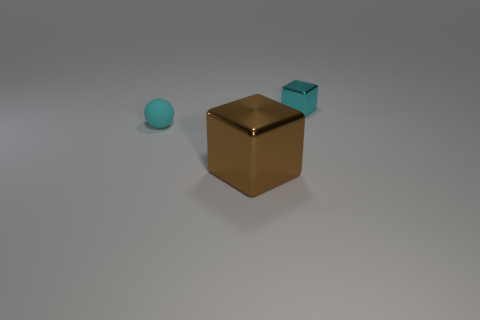Subtract all brown blocks. How many blocks are left? 1 Add 1 small brown objects. How many objects exist? 4 Subtract all spheres. How many objects are left? 2 Subtract all gray blocks. Subtract all yellow cylinders. How many blocks are left? 2 Subtract all purple balls. How many cyan blocks are left? 1 Subtract all big cyan shiny balls. Subtract all brown metallic things. How many objects are left? 2 Add 3 small cubes. How many small cubes are left? 4 Add 2 gray shiny cylinders. How many gray shiny cylinders exist? 2 Subtract 0 purple balls. How many objects are left? 3 